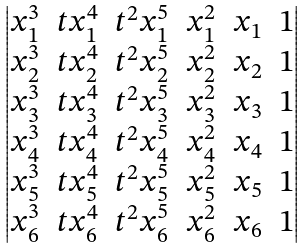Convert formula to latex. <formula><loc_0><loc_0><loc_500><loc_500>\begin{vmatrix} x _ { 1 } ^ { 3 } & t x _ { 1 } ^ { 4 } & t ^ { 2 } x _ { 1 } ^ { 5 } & x _ { 1 } ^ { 2 } & x _ { 1 } & 1 \\ x _ { 2 } ^ { 3 } & t x _ { 2 } ^ { 4 } & t ^ { 2 } x _ { 2 } ^ { 5 } & x _ { 2 } ^ { 2 } & x _ { 2 } & 1 \\ x _ { 3 } ^ { 3 } & t x _ { 3 } ^ { 4 } & t ^ { 2 } x _ { 3 } ^ { 5 } & x _ { 3 } ^ { 2 } & x _ { 3 } & 1 \\ x _ { 4 } ^ { 3 } & t x _ { 4 } ^ { 4 } & t ^ { 2 } x _ { 4 } ^ { 5 } & x _ { 4 } ^ { 2 } & x _ { 4 } & 1 \\ x _ { 5 } ^ { 3 } & t x _ { 5 } ^ { 4 } & t ^ { 2 } x _ { 5 } ^ { 5 } & x _ { 5 } ^ { 2 } & x _ { 5 } & 1 \\ x _ { 6 } ^ { 3 } & t x _ { 6 } ^ { 4 } & t ^ { 2 } x _ { 6 } ^ { 5 } & x _ { 6 } ^ { 2 } & x _ { 6 } & 1 \end{vmatrix}</formula> 